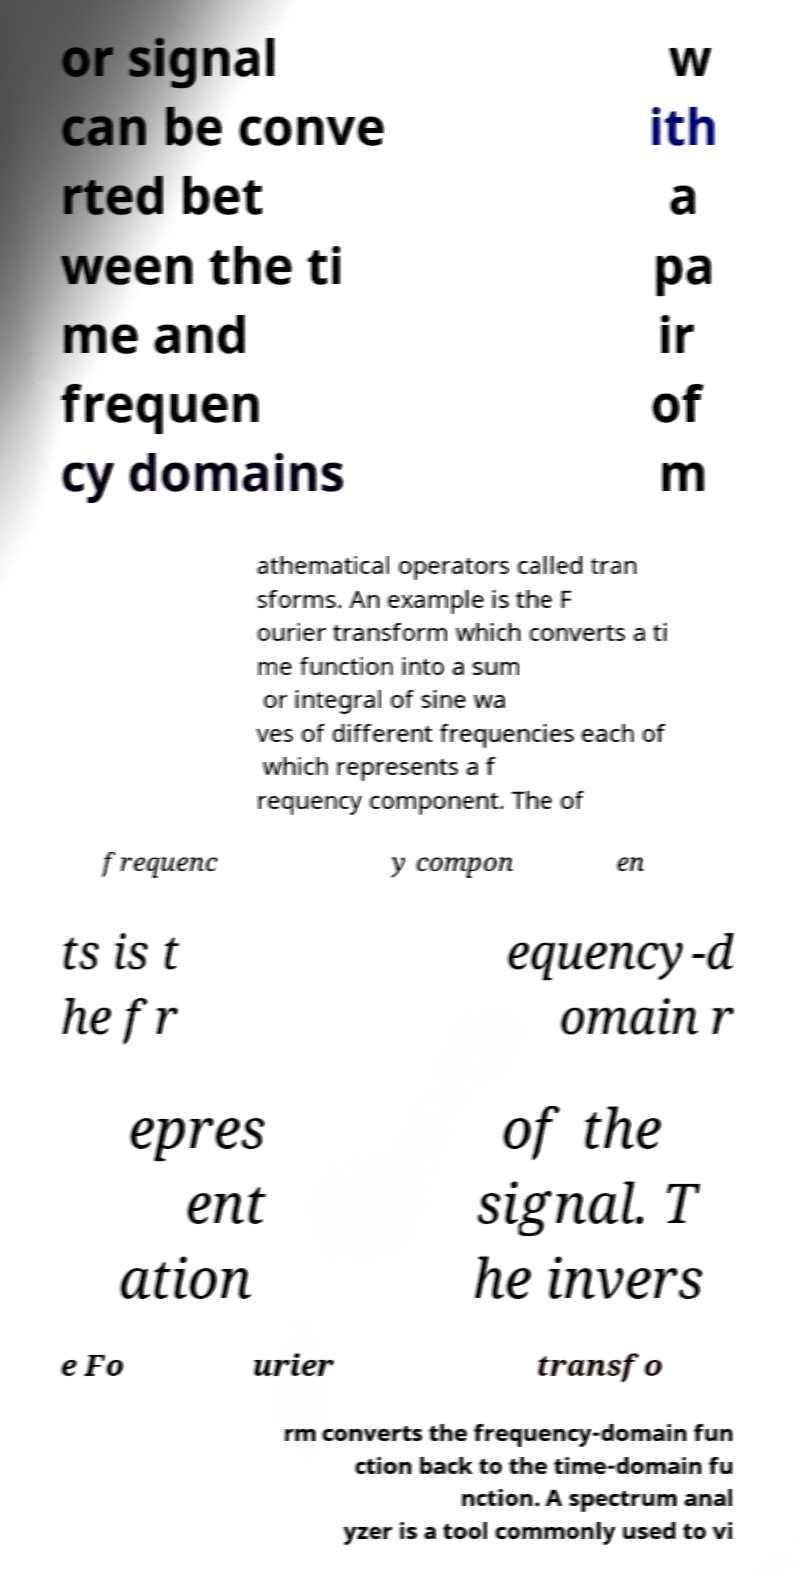Can you accurately transcribe the text from the provided image for me? or signal can be conve rted bet ween the ti me and frequen cy domains w ith a pa ir of m athematical operators called tran sforms. An example is the F ourier transform which converts a ti me function into a sum or integral of sine wa ves of different frequencies each of which represents a f requency component. The of frequenc y compon en ts is t he fr equency-d omain r epres ent ation of the signal. T he invers e Fo urier transfo rm converts the frequency-domain fun ction back to the time-domain fu nction. A spectrum anal yzer is a tool commonly used to vi 